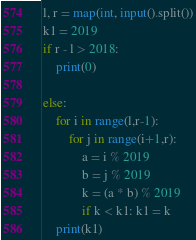<code> <loc_0><loc_0><loc_500><loc_500><_Python_>
l, r = map(int, input().split())
k1 = 2019
if r - l > 2018:
    print(0)

else:
    for i in range(l,r-1):
        for j in range(i+1,r):
            a = i % 2019
            b = j % 2019
            k = (a * b) % 2019
            if k < k1: k1 = k
    print(k1)



</code> 